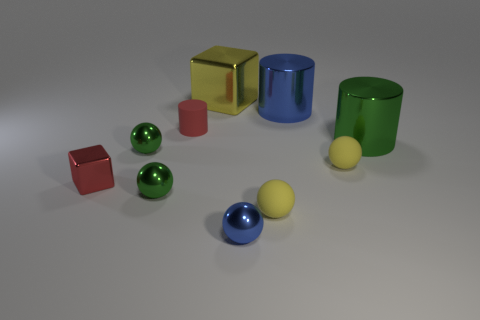Subtract all matte cylinders. How many cylinders are left? 2 Subtract all yellow cubes. How many green spheres are left? 2 Subtract 1 spheres. How many spheres are left? 4 Subtract all cubes. How many objects are left? 8 Subtract all blue cylinders. How many cylinders are left? 2 Subtract all yellow cylinders. Subtract all purple balls. How many cylinders are left? 3 Subtract all big red metallic objects. Subtract all blue metal balls. How many objects are left? 9 Add 2 metallic objects. How many metallic objects are left? 9 Add 5 purple metal cylinders. How many purple metal cylinders exist? 5 Subtract 0 purple spheres. How many objects are left? 10 